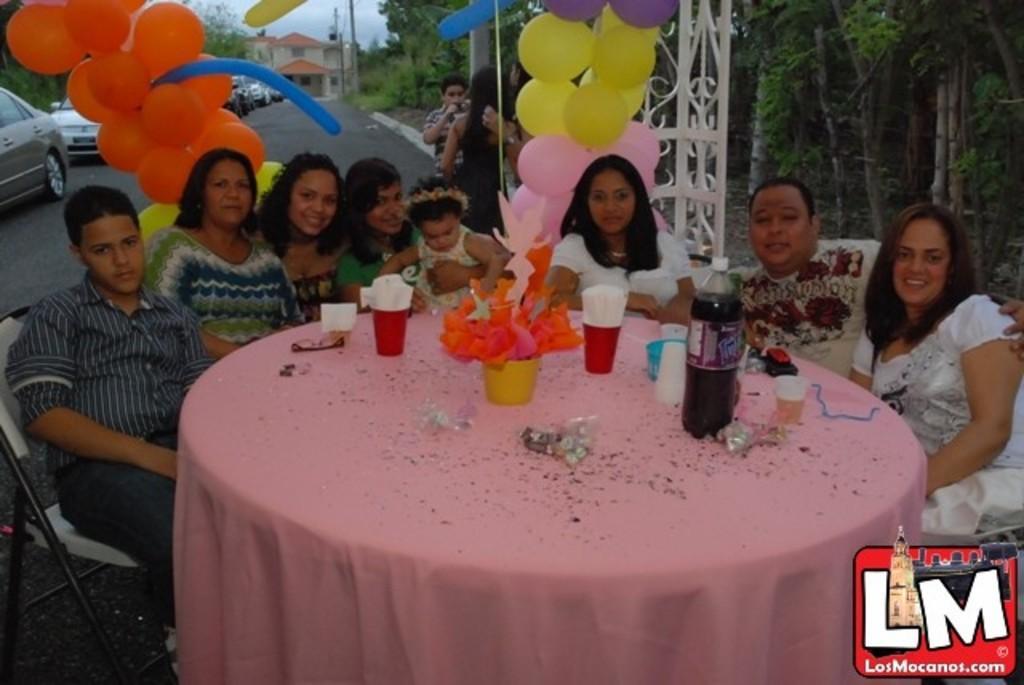Can you describe this image briefly? In the center of the image there is a table On the table we can see some objects, bottle, glasses, tissue papers, spectacles, cloth are present. In the middle of the image some persons are sitting on the chair. At the top of the image we can see some balloons, cars, trees, house, poles, sky are there. At the bottom of the image road is present. 